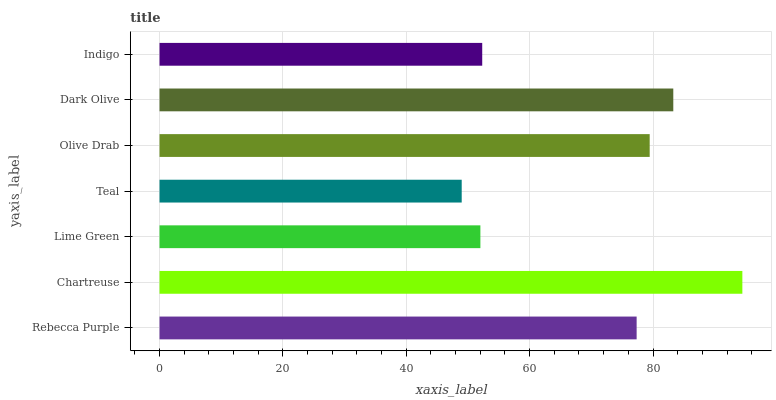Is Teal the minimum?
Answer yes or no. Yes. Is Chartreuse the maximum?
Answer yes or no. Yes. Is Lime Green the minimum?
Answer yes or no. No. Is Lime Green the maximum?
Answer yes or no. No. Is Chartreuse greater than Lime Green?
Answer yes or no. Yes. Is Lime Green less than Chartreuse?
Answer yes or no. Yes. Is Lime Green greater than Chartreuse?
Answer yes or no. No. Is Chartreuse less than Lime Green?
Answer yes or no. No. Is Rebecca Purple the high median?
Answer yes or no. Yes. Is Rebecca Purple the low median?
Answer yes or no. Yes. Is Teal the high median?
Answer yes or no. No. Is Lime Green the low median?
Answer yes or no. No. 